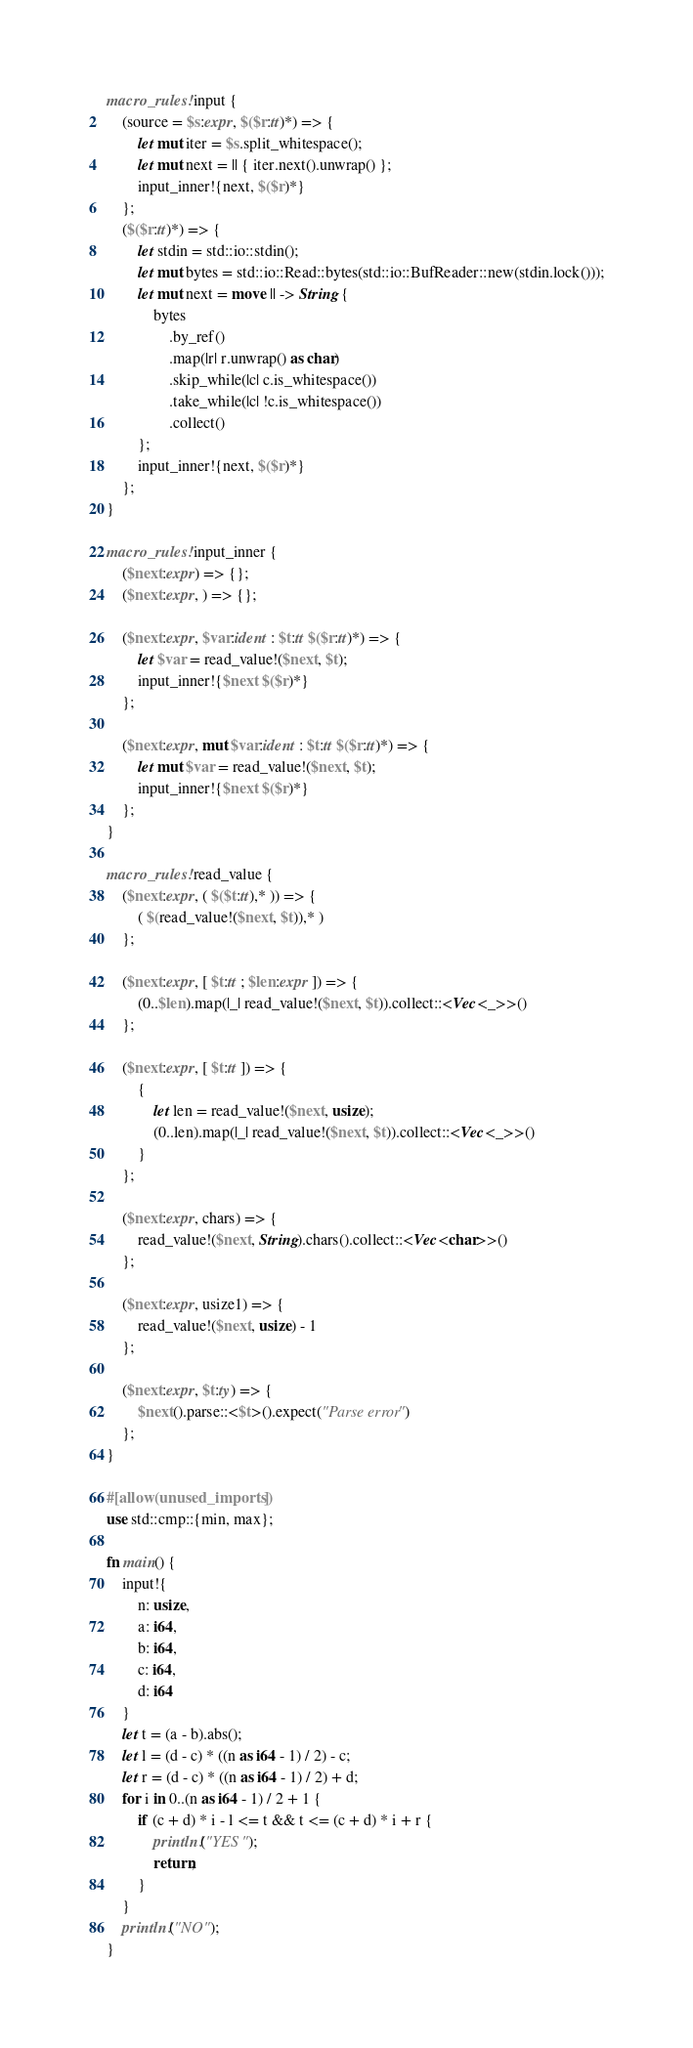Convert code to text. <code><loc_0><loc_0><loc_500><loc_500><_Rust_>macro_rules! input {
    (source = $s:expr, $($r:tt)*) => {
        let mut iter = $s.split_whitespace();
        let mut next = || { iter.next().unwrap() };
        input_inner!{next, $($r)*}
    };
    ($($r:tt)*) => {
        let stdin = std::io::stdin();
        let mut bytes = std::io::Read::bytes(std::io::BufReader::new(stdin.lock()));
        let mut next = move || -> String {
            bytes
                .by_ref()
                .map(|r| r.unwrap() as char)
                .skip_while(|c| c.is_whitespace())
                .take_while(|c| !c.is_whitespace())
                .collect()
        };
        input_inner!{next, $($r)*}
    };
}

macro_rules! input_inner {
    ($next:expr) => {};
    ($next:expr, ) => {};

    ($next:expr, $var:ident : $t:tt $($r:tt)*) => {
        let $var = read_value!($next, $t);
        input_inner!{$next $($r)*}
    };

    ($next:expr, mut $var:ident : $t:tt $($r:tt)*) => {
        let mut $var = read_value!($next, $t);
        input_inner!{$next $($r)*}
    };
}

macro_rules! read_value {
    ($next:expr, ( $($t:tt),* )) => {
        ( $(read_value!($next, $t)),* )
    };

    ($next:expr, [ $t:tt ; $len:expr ]) => {
        (0..$len).map(|_| read_value!($next, $t)).collect::<Vec<_>>()
    };

    ($next:expr, [ $t:tt ]) => {
        {
            let len = read_value!($next, usize);
            (0..len).map(|_| read_value!($next, $t)).collect::<Vec<_>>()
        }
    };

    ($next:expr, chars) => {
        read_value!($next, String).chars().collect::<Vec<char>>()
    };

    ($next:expr, usize1) => {
        read_value!($next, usize) - 1
    };

    ($next:expr, $t:ty) => {
        $next().parse::<$t>().expect("Parse error")
    };
}

#[allow(unused_imports)]
use std::cmp::{min, max};

fn main() {
    input!{
        n: usize,
        a: i64,
        b: i64,
        c: i64,
        d: i64
    }
    let t = (a - b).abs();
    let l = (d - c) * ((n as i64 - 1) / 2) - c;
    let r = (d - c) * ((n as i64 - 1) / 2) + d;
    for i in 0..(n as i64 - 1) / 2 + 1 {
        if (c + d) * i - l <= t && t <= (c + d) * i + r {
            println!("YES");
            return;
        }
    }
    println!("NO");
}
</code> 